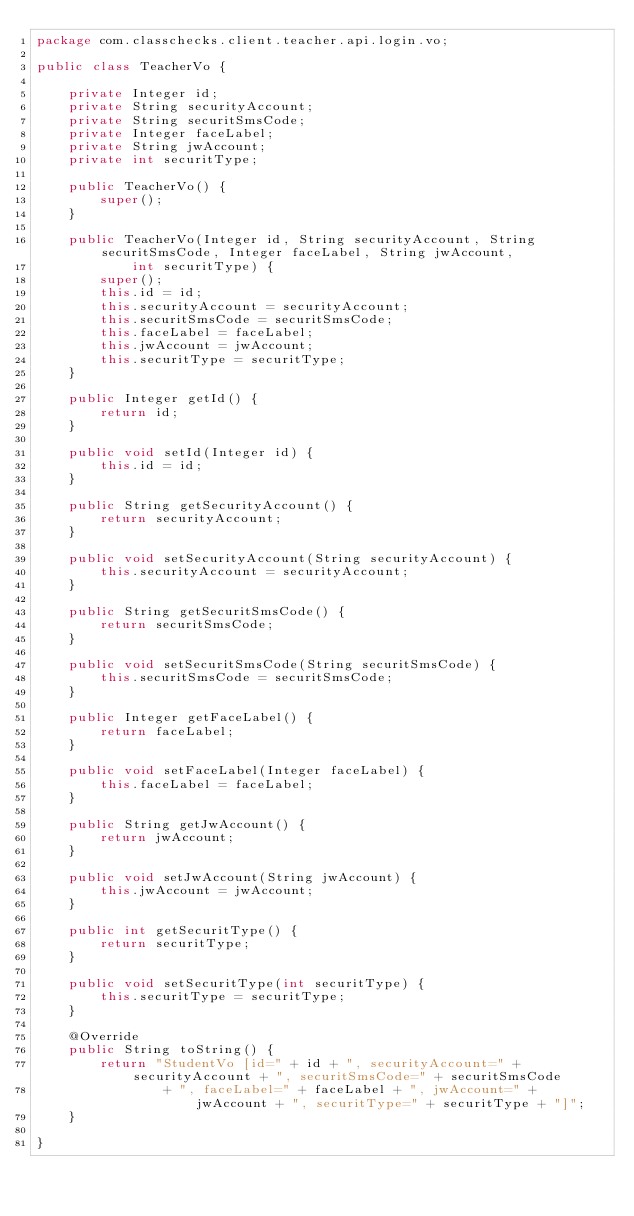<code> <loc_0><loc_0><loc_500><loc_500><_Java_>package com.classchecks.client.teacher.api.login.vo;

public class TeacherVo {

	private Integer id;
	private String securityAccount;
	private String securitSmsCode;
	private Integer faceLabel;
	private String jwAccount;
	private int securitType;

	public TeacherVo() {
		super();
	}

	public TeacherVo(Integer id, String securityAccount, String securitSmsCode, Integer faceLabel, String jwAccount,
			int securitType) {
		super();
		this.id = id;
		this.securityAccount = securityAccount;
		this.securitSmsCode = securitSmsCode;
		this.faceLabel = faceLabel;
		this.jwAccount = jwAccount;
		this.securitType = securitType;
	}

	public Integer getId() {
		return id;
	}

	public void setId(Integer id) {
		this.id = id;
	}

	public String getSecurityAccount() {
		return securityAccount;
	}

	public void setSecurityAccount(String securityAccount) {
		this.securityAccount = securityAccount;
	}

	public String getSecuritSmsCode() {
		return securitSmsCode;
	}

	public void setSecuritSmsCode(String securitSmsCode) {
		this.securitSmsCode = securitSmsCode;
	}

	public Integer getFaceLabel() {
		return faceLabel;
	}

	public void setFaceLabel(Integer faceLabel) {
		this.faceLabel = faceLabel;
	}

	public String getJwAccount() {
		return jwAccount;
	}

	public void setJwAccount(String jwAccount) {
		this.jwAccount = jwAccount;
	}

	public int getSecuritType() {
		return securitType;
	}

	public void setSecuritType(int securitType) {
		this.securitType = securitType;
	}

	@Override
	public String toString() {
		return "StudentVo [id=" + id + ", securityAccount=" + securityAccount + ", securitSmsCode=" + securitSmsCode
				+ ", faceLabel=" + faceLabel + ", jwAccount=" + jwAccount + ", securitType=" + securitType + "]";
	}

}
</code> 